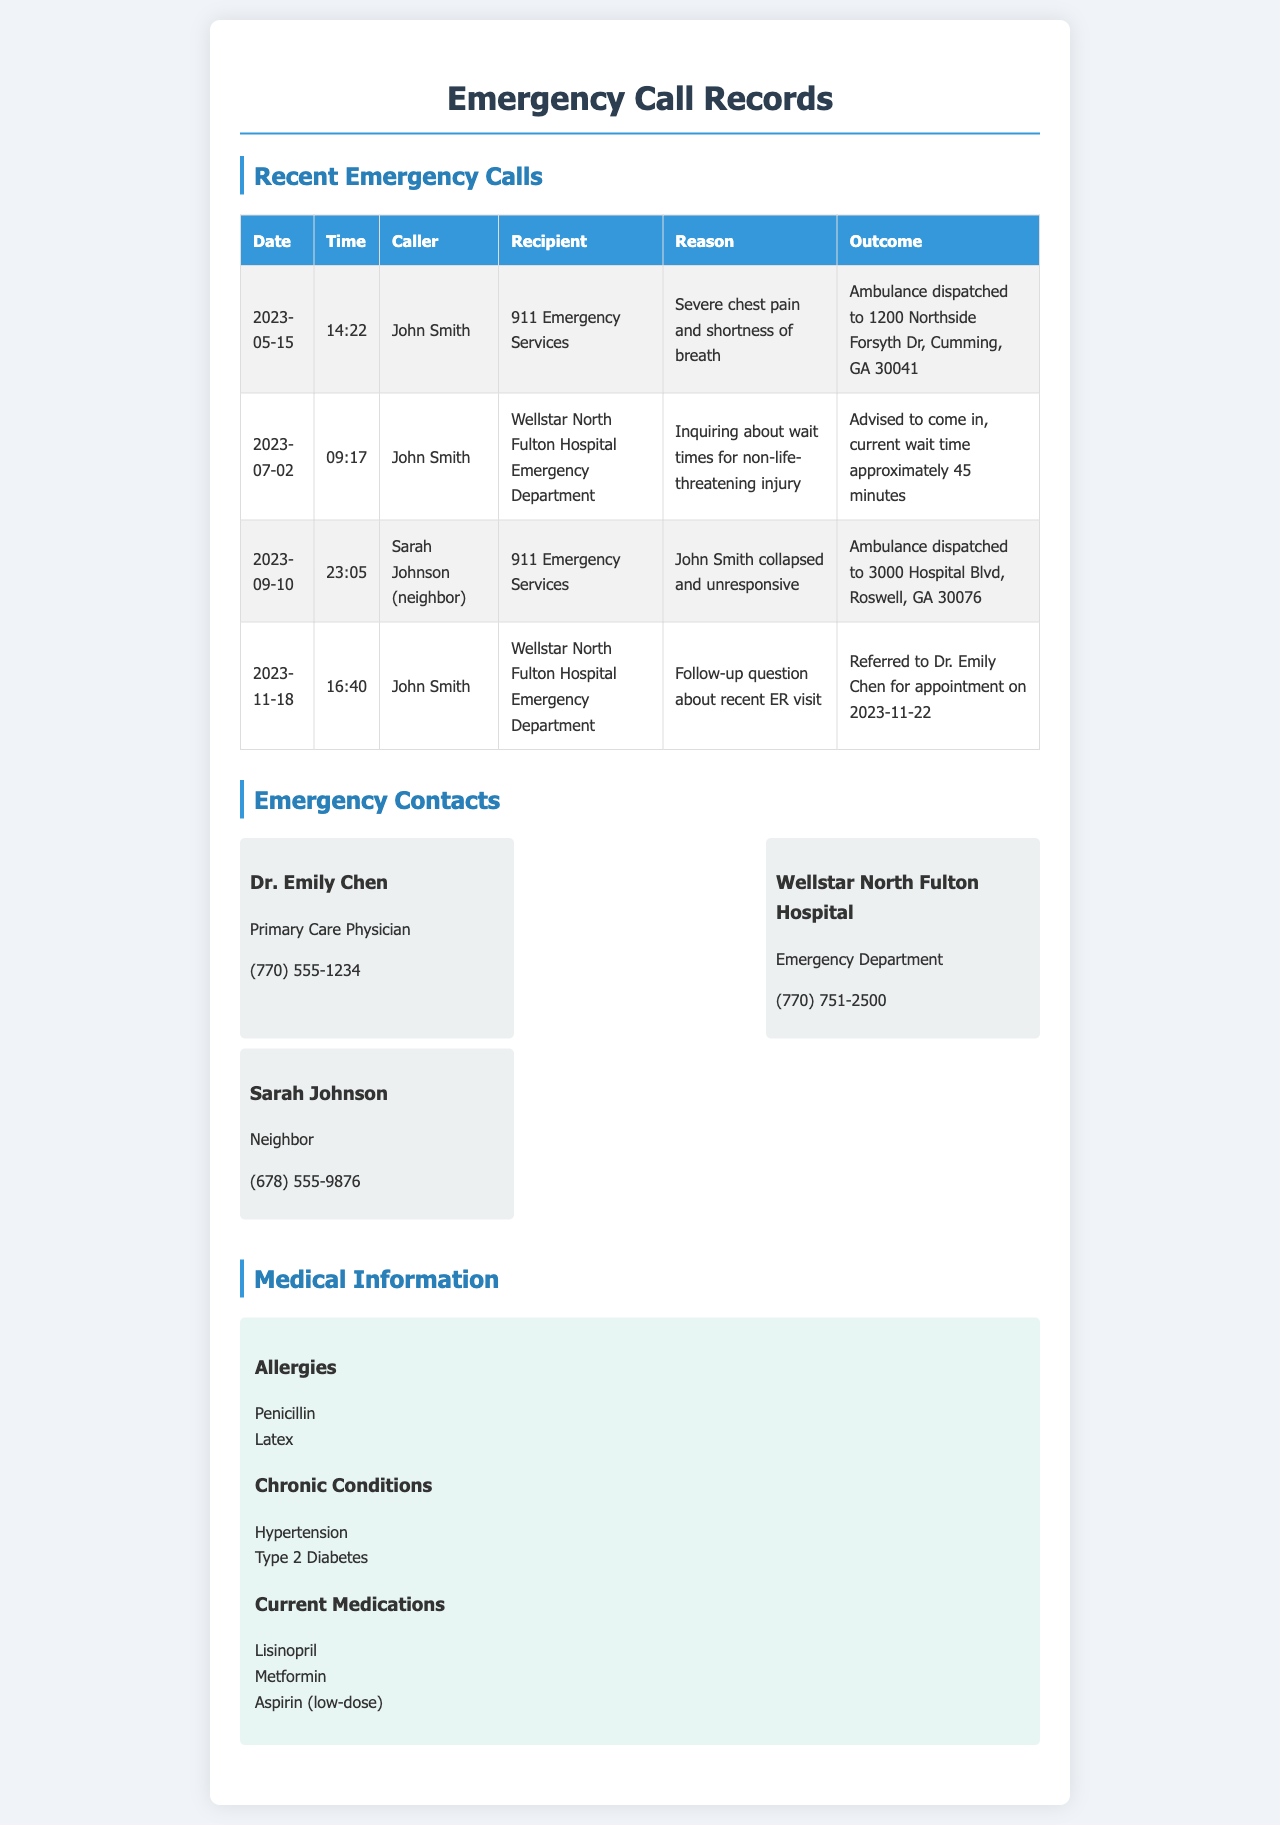what is the date of the first emergency call? The first emergency call in the document is dated May 15, 2023.
Answer: May 15, 2023 who was the caller for the call about the wait times? The caller for the wait times inquiry was John Smith.
Answer: John Smith what was the reason for Sarah Johnson's call on September 10? Sarah Johnson called because John Smith collapsed and was unresponsive.
Answer: John Smith collapsed and unresponsive what is the outcome of the call made on November 18? The outcome of the call made on November 18 was a referral to Dr. Emily Chen for an appointment.
Answer: Referred to Dr. Emily Chen for appointment how long was the wait time advised during the call on July 2? The advised wait time during the call on July 2 was approximately 45 minutes.
Answer: approximately 45 minutes which emergency department was contacted on July 2? The emergency department contacted on July 2 was Wellstar North Fulton Hospital Emergency Department.
Answer: Wellstar North Fulton Hospital Emergency Department who is listed as the primary care physician? The primary care physician listed in the emergency contacts is Dr. Emily Chen.
Answer: Dr. Emily Chen how many chronic conditions are mentioned in the medical information? There are two chronic conditions mentioned: Hypertension and Type 2 Diabetes.
Answer: two what medications are currently taken as listed in the document? The current medications listed are Lisinopril, Metformin, and Aspirin (low-dose).
Answer: Lisinopril, Metformin, Aspirin (low-dose) 